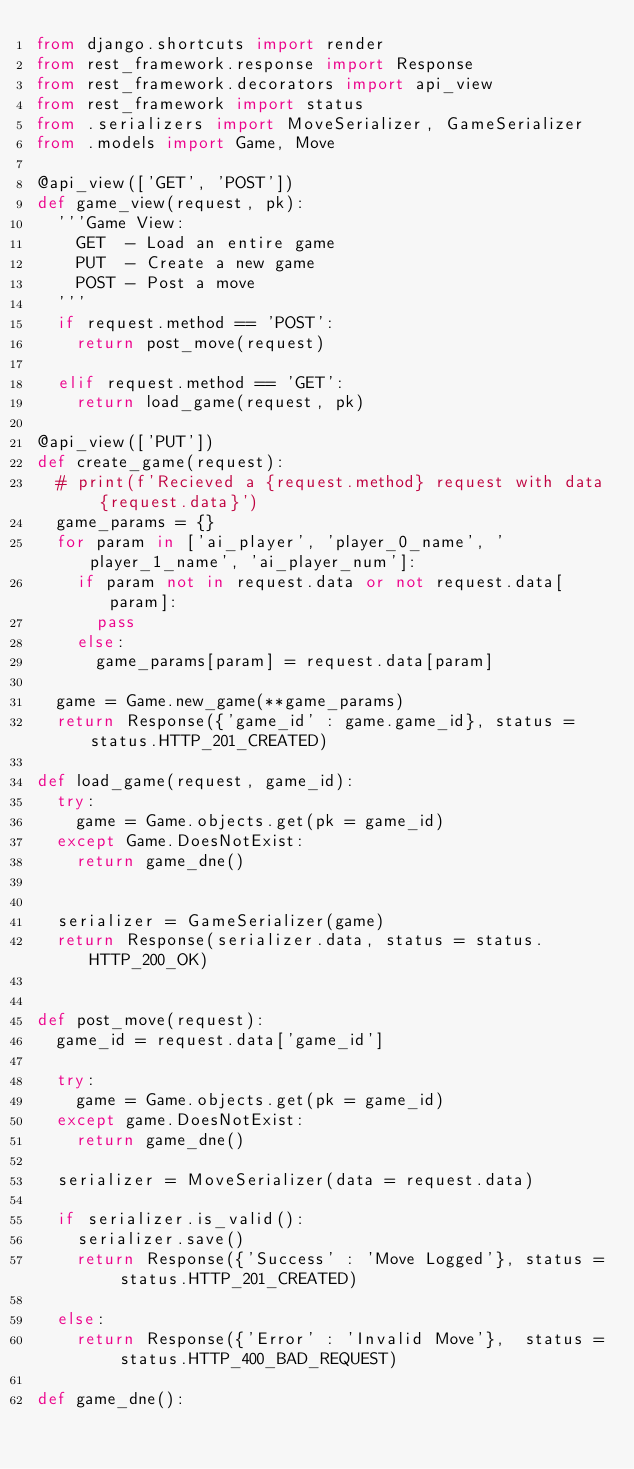<code> <loc_0><loc_0><loc_500><loc_500><_Python_>from django.shortcuts import render
from rest_framework.response import Response
from rest_framework.decorators import api_view
from rest_framework import status
from .serializers import MoveSerializer, GameSerializer
from .models import Game, Move

@api_view(['GET', 'POST'])
def game_view(request, pk):
  '''Game View:
    GET  - Load an entire game
    PUT  - Create a new game
    POST - Post a move
  '''
  if request.method == 'POST':
    return post_move(request)

  elif request.method == 'GET':
    return load_game(request, pk)

@api_view(['PUT'])
def create_game(request):
  # print(f'Recieved a {request.method} request with data {request.data}')
  game_params = {}
  for param in ['ai_player', 'player_0_name', 'player_1_name', 'ai_player_num']:
    if param not in request.data or not request.data[param]:
      pass
    else:
      game_params[param] = request.data[param]

  game = Game.new_game(**game_params)
  return Response({'game_id' : game.game_id}, status = status.HTTP_201_CREATED)

def load_game(request, game_id):
  try:
    game = Game.objects.get(pk = game_id)
  except Game.DoesNotExist:
    return game_dne()


  serializer = GameSerializer(game)
  return Response(serializer.data, status = status.HTTP_200_OK)


def post_move(request):
  game_id = request.data['game_id']

  try:
    game = Game.objects.get(pk = game_id)
  except game.DoesNotExist:
    return game_dne()

  serializer = MoveSerializer(data = request.data)

  if serializer.is_valid():
    serializer.save()
    return Response({'Success' : 'Move Logged'}, status = status.HTTP_201_CREATED)

  else:
    return Response({'Error' : 'Invalid Move'},  status = status.HTTP_400_BAD_REQUEST)

def game_dne():</code> 